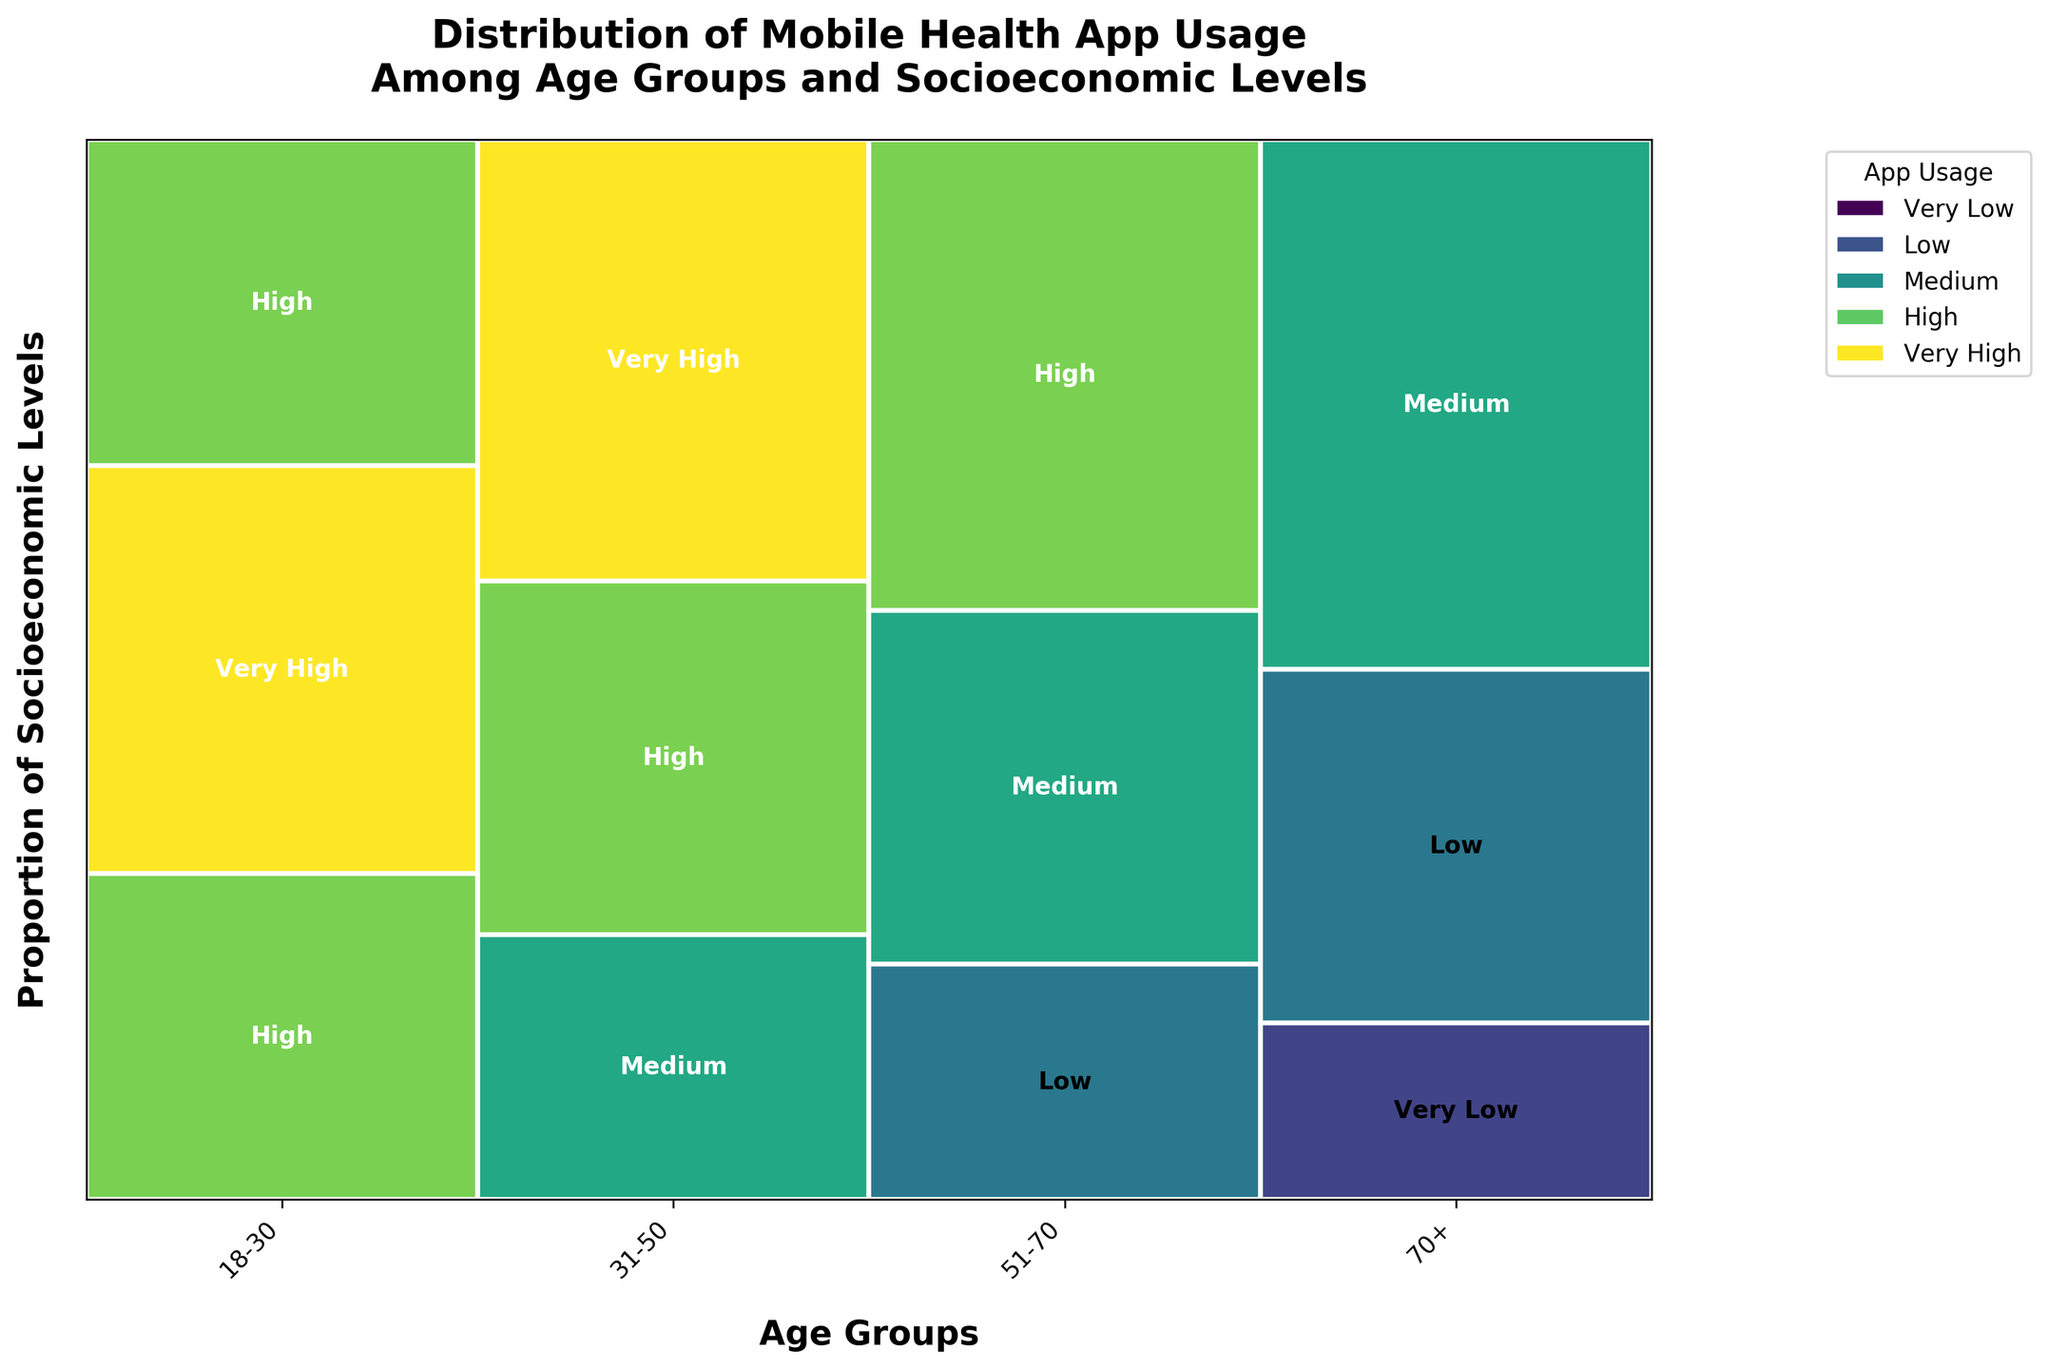What's the title of the figure? The title is shown at the top of the figure. It reads: "Distribution of Mobile Health App Usage Among Age Groups and Socioeconomic Levels".
Answer: Distribution of Mobile Health App Usage Among Age Groups and Socioeconomic Levels Which age group has a "Very High" usage in the "High Income" category? Look at the section for "High Income" within the different age groups and identify which group shows "Very High" usage.
Answer: 31-50 Which socioeconomic level has the highest app usage in the 51-70 age group? Within the 51-70 age group, compare the different sections for Low Income, Middle Income, and High Income. The "High" usage in "High Income" marks the highest app usage.
Answer: High Income Between the age groups 18-30 and 51-70, which has a larger proportion of high app usage (High or Very High) across all socioeconomic levels? Calculate the total high usage (High and Very High) proportions for both age groups and compare. The 18-30 age group includes High and Very High more frequently.
Answer: 18-30 What is the most common app usage classification for the 70+ age group? Look at each section (Low Income, Middle Income, High Income) within the 70+ age group and identify the most frequent app usage classification. "Low" appears twice, once in Low Income and once in Middle Income.
Answer: Low How does app usage in the Low Income category compare between the 31-50 age group and the 51-70 age group? Compare the sections of Low Income in both the 31-50 and 51-70 age groups. The 31-50 age group shows Medium usage, while the 51-70 group shows Low usage.
Answer: 31-50 (Medium), 51-70 (Low) What is the least common app usage classification in the 51-70 age group? Look at the app usage across Low Income, Middle Income, and High Income sections in the 51-70 age group and identify the least common classification. "Very Low" does not appear at all in this age group.
Answer: Very Low Does any age group have "Very Low" app usage for any socioeconomic level? Scan all age groups and socioeconomic levels to see if "Very Low" appears. It only appears in the Low Income category of the 70+ age group.
Answer: Yes Compare the proportion of "Medium" app usage between the Middle Income category of the 51-70 age group and the High Income category of the 70+ age group. Look at the "Medium" slices in both categories: Middle Income of 51-70 and High Income of 70+. Both these categories have "Medium" usage but in different proportions relative to their group totals.
Answer: 51-70 Middle Income: Medium, 70+ High Income: Medium What is represented on the x-axis of the mosaic plot? Identify what is labeled and represented along the horizontal axis of the figure. The x-axis represents different age groups of the population.
Answer: Age groups 